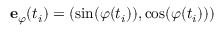Convert formula to latex. <formula><loc_0><loc_0><loc_500><loc_500>e _ { \varphi } ( t _ { i } ) = ( \sin ( \varphi ( t _ { i } ) ) , \cos ( \varphi ( t _ { i } ) ) )</formula> 